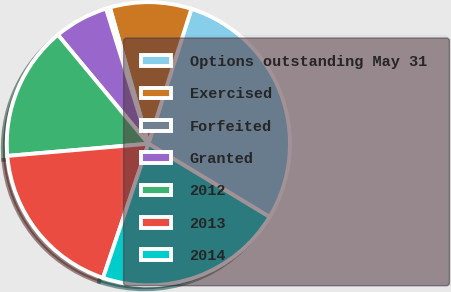Convert chart. <chart><loc_0><loc_0><loc_500><loc_500><pie_chart><fcel>Options outstanding May 31<fcel>Exercised<fcel>Forfeited<fcel>Granted<fcel>2012<fcel>2013<fcel>2014<nl><fcel>28.73%<fcel>9.3%<fcel>0.45%<fcel>6.2%<fcel>15.34%<fcel>18.44%<fcel>21.54%<nl></chart> 